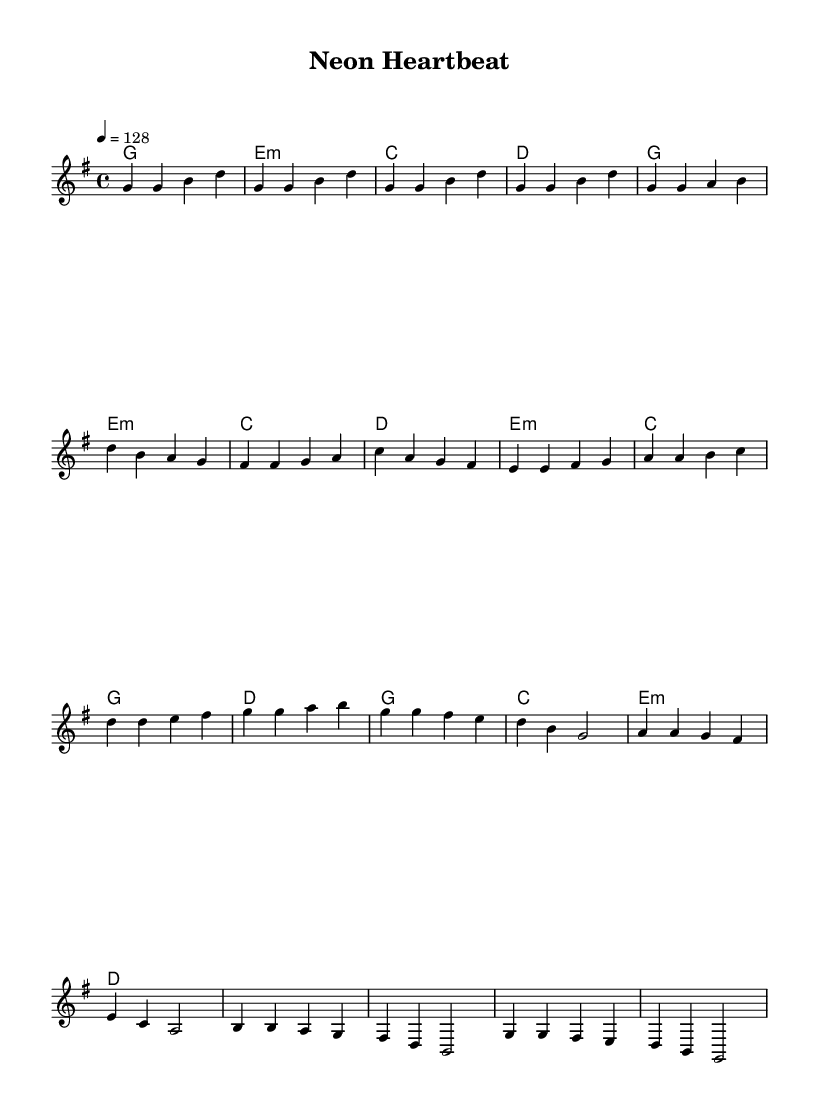What is the key signature of this music? The key signature indicated in the music is G major, which has one sharp (F#). This can be determined by visually checking the key signature at the beginning of the staff.
Answer: G major What is the time signature of this music? The time signature shown at the beginning of the score is 4/4, which means there are four beats in a measure and the quarter note gets one beat. This is clearly marked in the sheet music.
Answer: 4/4 What is the tempo marking for this piece? The tempo marking specified in the music is "4 = 128," meaning there are 128 quarter note beats per minute. This is indicated in the tempo notation found at the start of the score.
Answer: 128 How many measures are in the verse section? The verse section consists of two lines of measures, and each line contains four measures, totaling eight measures. By counting each measure in the designated verse section, we can determine this sum.
Answer: Eight What is the first note of the chorus? The first note of the chorus is G. This can be deduced by looking at the first note on the staff in the chorus section marked in the music.
Answer: G What chords are used in the pre-chorus section? The chords in the pre-chorus section are E minor, C major, G major, and D major. By examining the chord symbols present above the staff during the pre-chorus measures, these can be identified.
Answer: E minor, C major, G major, D major How many beats does the first measure of the intro contain? The first measure of the intro contains four beats, all of which are quarter notes. This is determined by analyzing the note values in the measure, which clearly indicate the total beats.
Answer: Four 